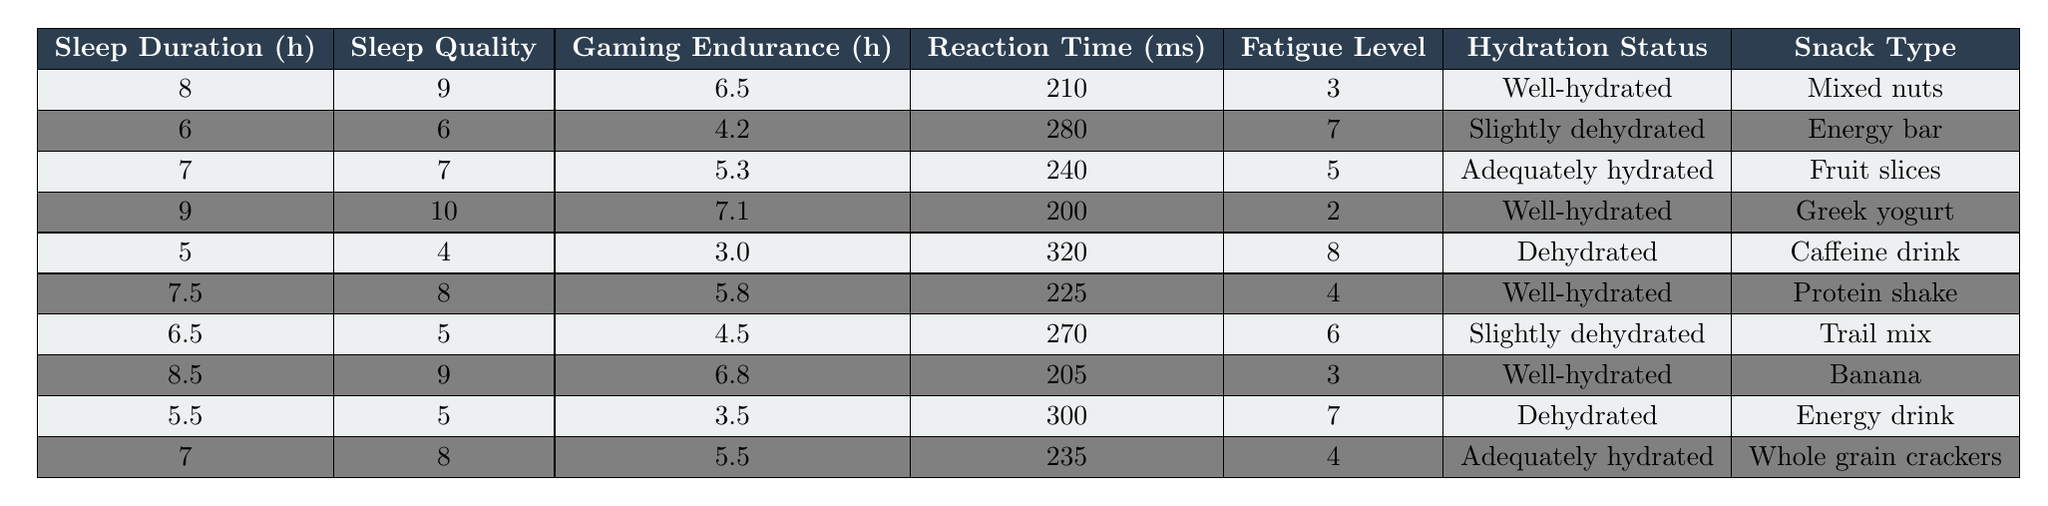What is the highest gaming endurance recorded in the table? The highest gaming endurance can be found by reviewing the "Gaming Endurance" column. The highest value listed is 7.1 hours, which corresponds to the entry with 9 hours of sleep and a sleep quality of 10.
Answer: 7.1 hours Which snack type corresponds to the lowest fatigue level? We look at the "Fatigue Level" column to find the lowest value, which is 2. Checking the corresponding entry reveals that the snack type is "Greek yogurt".
Answer: Greek yogurt What is the average sleep duration from the table? To find the average sleep duration, we sum the values in the "Sleep Duration" column: (8 + 6 + 7 + 9 + 5 + 7.5 + 6.5 + 8.5 + 5.5 + 7) = 70.5 hours. There are 10 entries, so we divide by 10: 70.5 / 10 = 7.05.
Answer: 7.05 hours Is there a correlation between sleep quality and gaming endurance based on the table? To analyze the correlation, we review the "Sleep Quality" and "Gaming Endurance" columns to see if higher sleep quality consistently associates with higher gaming endurance. In the table, higher sleep quality does generally lead to higher endurance, indicating a positive correlation. However, the correlation isn't perfect and requires deeper analysis for a concrete conclusion.
Answer: Yes, generally a positive correlation is present What is the difference in gaming endurance between the highest and the lowest sleep duration (from the table)? The maximum sleep duration is 9 hours with a gaming endurance of 7.1 hours, while the minimum is 5 hours with a gaming endurance of 3.0 hours. To find the difference: 7.1 - 3.0 = 4.1 hours.
Answer: 4.1 hours What hydration status is most commonly associated with high gaming endurance scores? Reviewing the "Gaming Endurance" column, we find that higher scores (above 6.0 hours) are predominantly associated with "Well-hydrated" status. Comparing entries for high endurance (7.1, 6.8, and 6.5) shows they all have this status.
Answer: Well-hydrated How many entries in the table have a sleep quality rating below 6? We count the entries in the "Sleep Quality" column that are below 6: there are 2 entries with values of 4 and 5, indicating that the total is 2.
Answer: 2 entries What is the average reaction time for well-hydrated individuals? To calculate the average reaction time, we look at the "Reaction Time" column for entries marked "Well-hydrated", which are 210, 200, 225, and 205 ms. The average is computed as (210 + 200 + 225 + 205) / 4 = 210 ms.
Answer: 210 ms Which snack type was consumed with the highest recorded fatigue level? The highest fatigue level in the table is 8, which is associated with the snack "Caffeine drink". This is found by identifying the entry with the highest fatigue level and checking the corresponding snack type.
Answer: Caffeine drink Does increased sleep duration generally lead to lower reaction times based on the data? Analyzing the table, we observe that lower reaction times (like 200 or 210 ms) do accompany higher sleep durations (9 hours and 8 hours, respectively). However, the entry with 6 hours of sleep has a 280 ms reaction time, which indicates variability. Therefore, while it seems plausible, more data would be needed to affirm the relationship definitively.
Answer: Generally, yes, but it's variable 